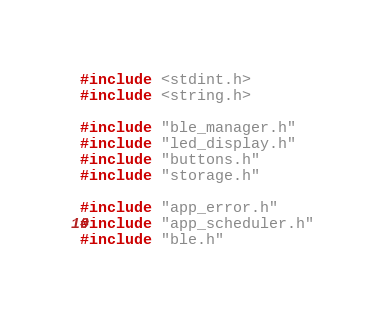<code> <loc_0><loc_0><loc_500><loc_500><_C_>#include <stdint.h>
#include <string.h>

#include "ble_manager.h"
#include "led_display.h"
#include "buttons.h"
#include "storage.h"

#include "app_error.h"
#include "app_scheduler.h"
#include "ble.h"</code> 